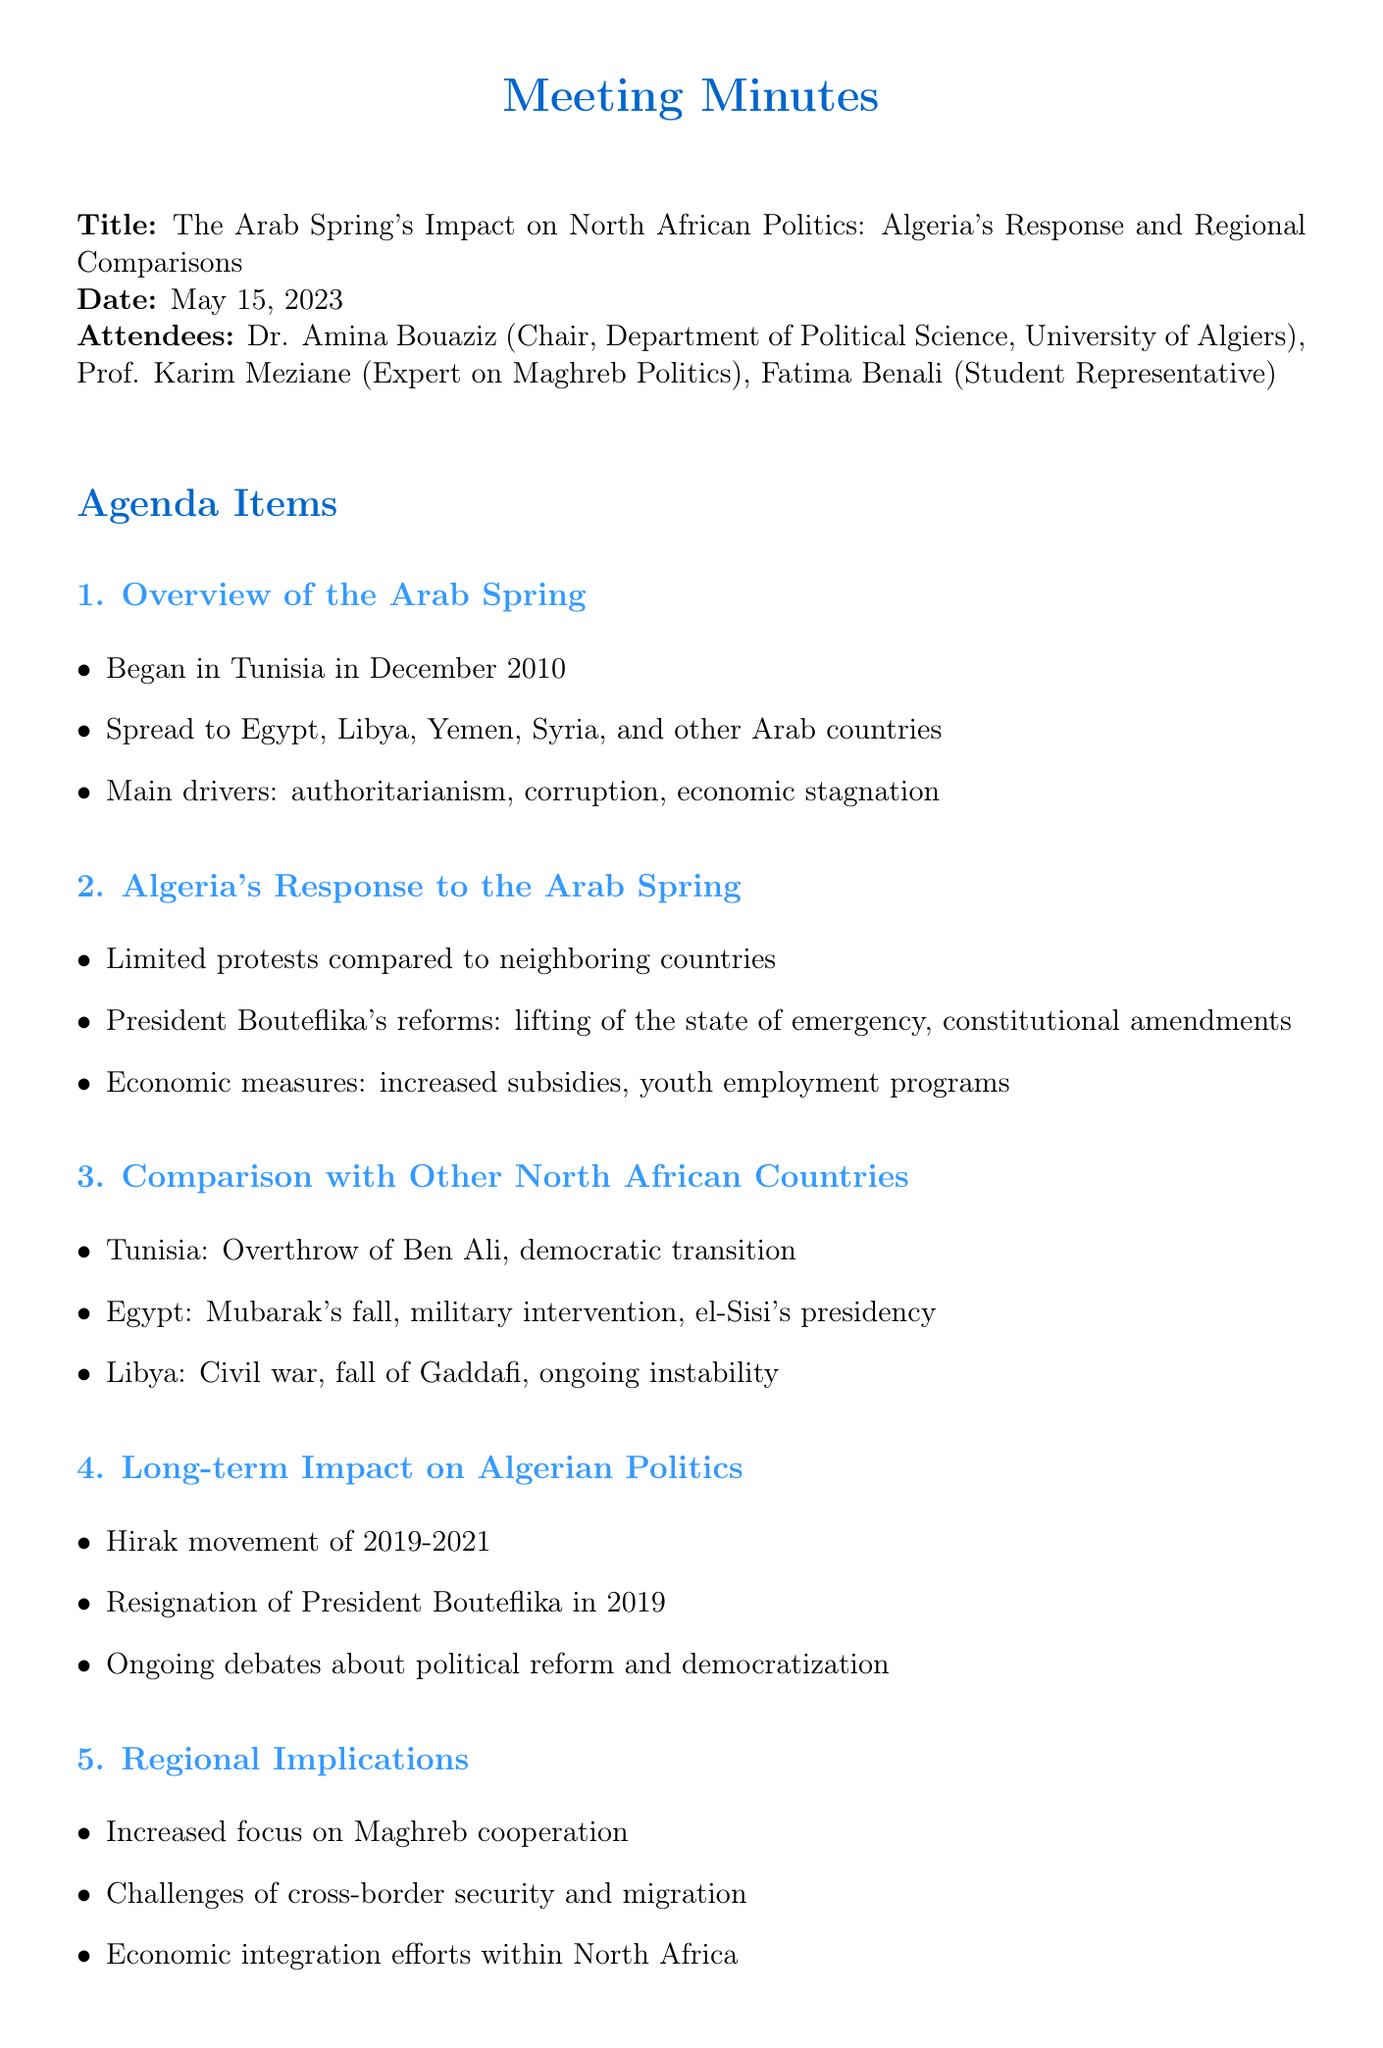What was the date of the meeting? The document states that the meeting took place on May 15, 2023.
Answer: May 15, 2023 Who chaired the meeting? Dr. Amina Bouaziz is listed as the Chair of the meeting.
Answer: Dr. Amina Bouaziz What were the main drivers of the Arab Spring? The document mentions that the main drivers included authoritarianism, corruption, and economic stagnation.
Answer: Authoritarianism, corruption, economic stagnation Which movement is associated with Algeria's long-term political impact? The document refers to the Hirak movement of 2019-2021 as significant for Algerian politics.
Answer: Hirak movement of 2019-2021 How did Algeria's response to protests compare to its neighbors? The document notes that Algeria had limited protests compared to neighboring countries.
Answer: Limited protests What is a key outcome of the Arab Spring in Tunisia? The meeting minutes highlight the overthrow of Ben Ali and the democratic transition in Tunisia.
Answer: Overthrow of Ben Ali, democratic transition Which economic measures were implemented in Algeria as a response to the Arab Spring? The document lists increased subsidies and youth employment programs as economic measures taken.
Answer: Increased subsidies, youth employment programs What does the conclusion of the document emphasize? The conclusion discusses varying impacts of the Arab Spring across North Africa and highlights Algeria's significant political awakening.
Answer: Varying impacts, significant political awakening What is one of the regional implications mentioned in the meeting minutes? The document refers to challenges of cross-border security and migration as a regional implication.
Answer: Challenges of cross-border security and migration 